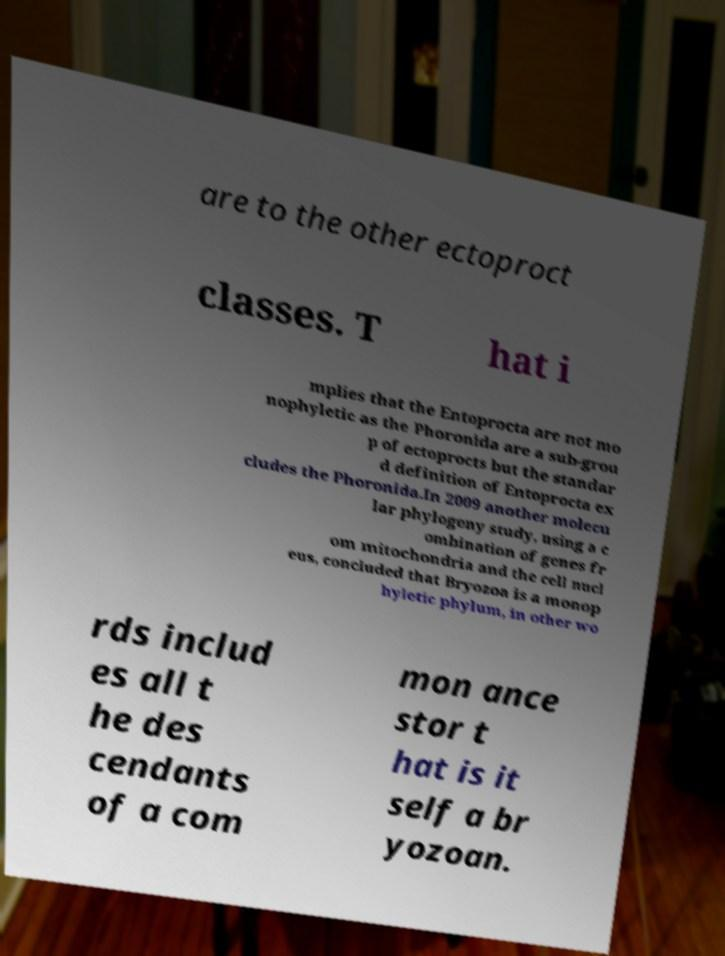Please read and relay the text visible in this image. What does it say? are to the other ectoproct classes. T hat i mplies that the Entoprocta are not mo nophyletic as the Phoronida are a sub-grou p of ectoprocts but the standar d definition of Entoprocta ex cludes the Phoronida.In 2009 another molecu lar phylogeny study, using a c ombination of genes fr om mitochondria and the cell nucl eus, concluded that Bryozoa is a monop hyletic phylum, in other wo rds includ es all t he des cendants of a com mon ance stor t hat is it self a br yozoan. 